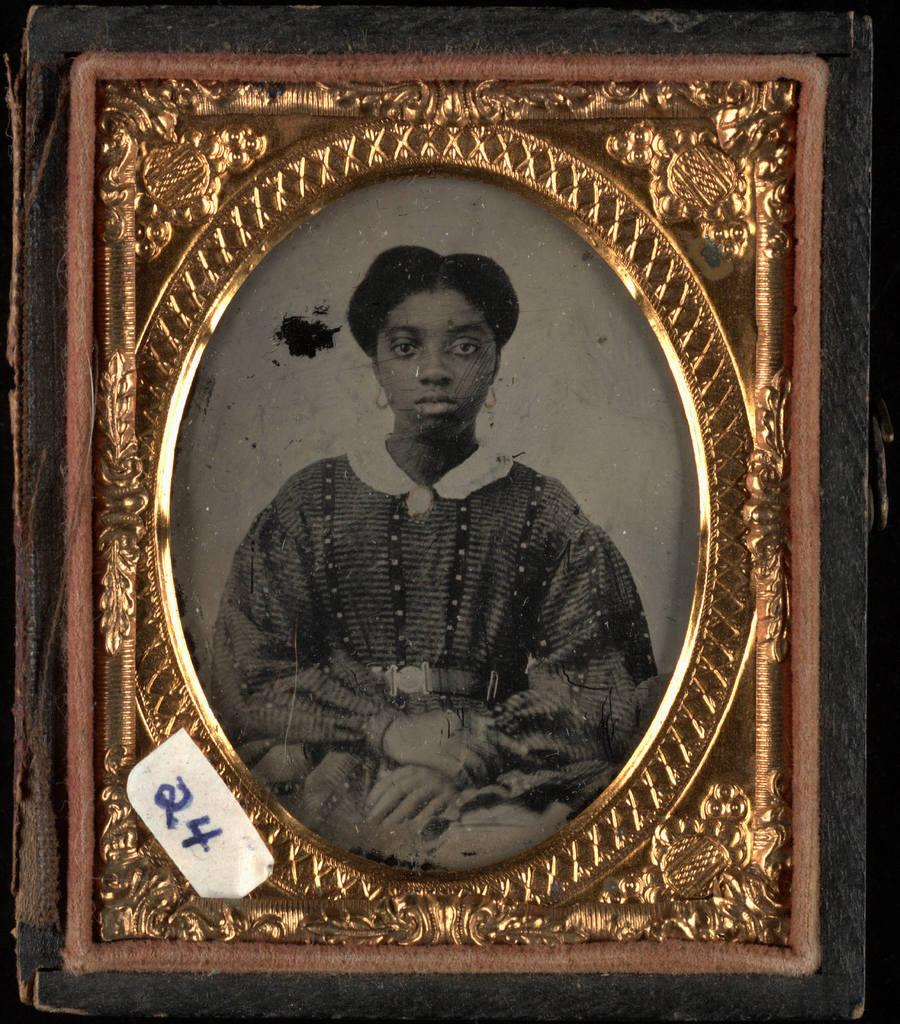What object in the image contains a picture? The photo frame in the image contains a picture of a woman. What is the content of the picture in the photo frame? The picture in the photo frame is of a woman. What else can be seen in the image besides the photo frame? There is a paper with written numbers in the image. How is the paper with written numbers positioned in the image? The paper is pasted on another surface. What type of ice can be seen melting on the seat in the image? There is no ice or seat present in the image; it only contains a photo frame and a paper with written numbers. 